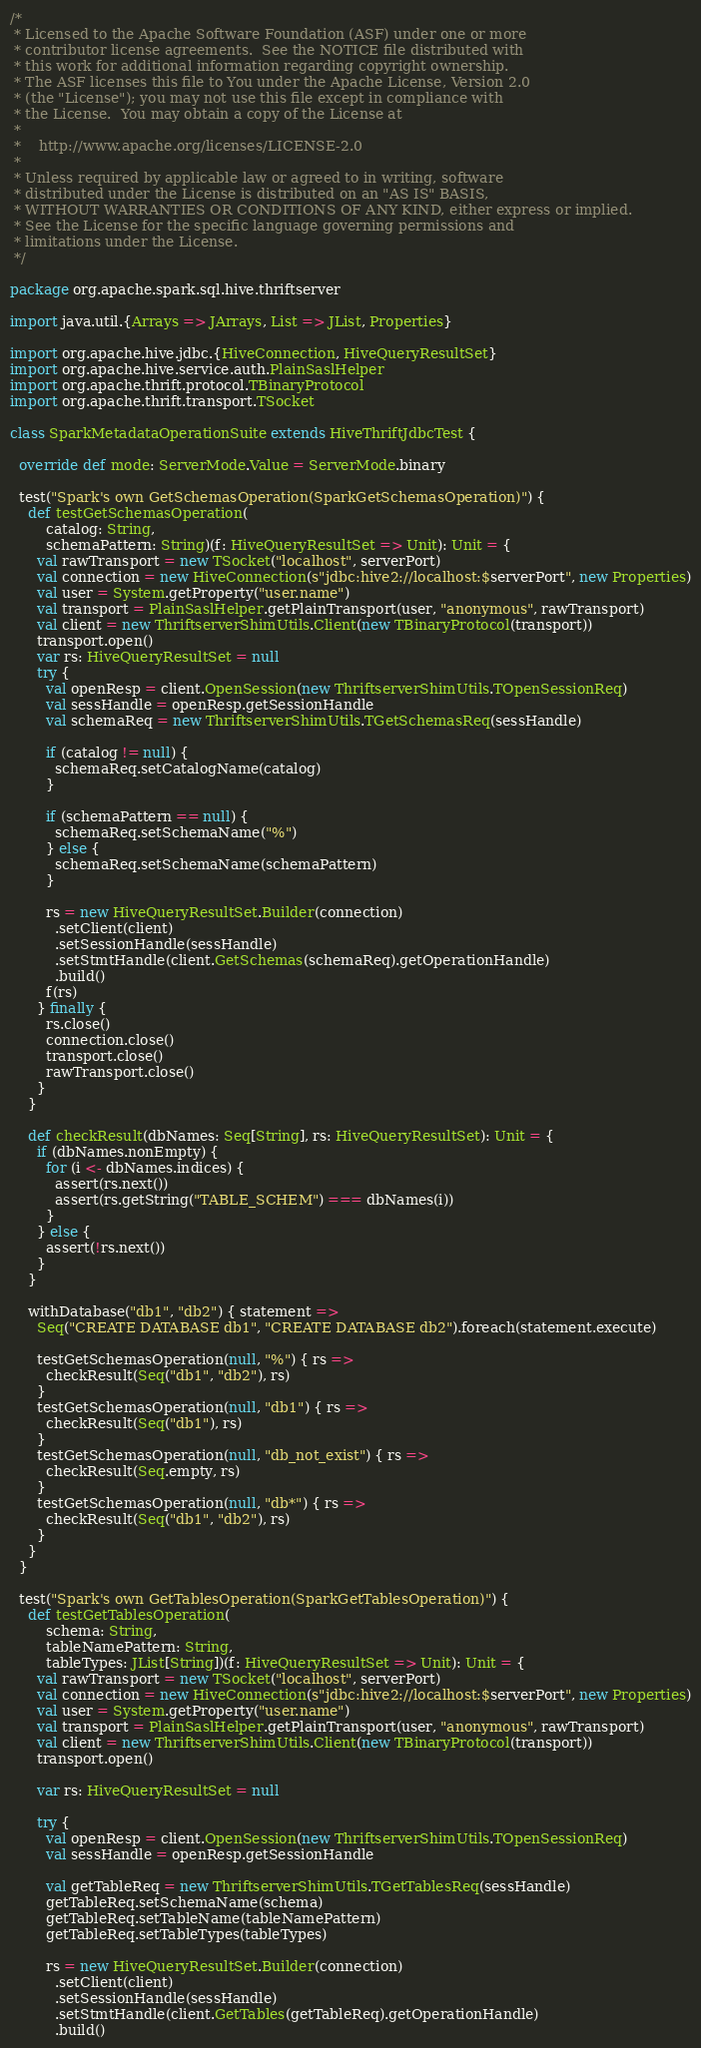<code> <loc_0><loc_0><loc_500><loc_500><_Scala_>/*
 * Licensed to the Apache Software Foundation (ASF) under one or more
 * contributor license agreements.  See the NOTICE file distributed with
 * this work for additional information regarding copyright ownership.
 * The ASF licenses this file to You under the Apache License, Version 2.0
 * (the "License"); you may not use this file except in compliance with
 * the License.  You may obtain a copy of the License at
 *
 *    http://www.apache.org/licenses/LICENSE-2.0
 *
 * Unless required by applicable law or agreed to in writing, software
 * distributed under the License is distributed on an "AS IS" BASIS,
 * WITHOUT WARRANTIES OR CONDITIONS OF ANY KIND, either express or implied.
 * See the License for the specific language governing permissions and
 * limitations under the License.
 */

package org.apache.spark.sql.hive.thriftserver

import java.util.{Arrays => JArrays, List => JList, Properties}

import org.apache.hive.jdbc.{HiveConnection, HiveQueryResultSet}
import org.apache.hive.service.auth.PlainSaslHelper
import org.apache.thrift.protocol.TBinaryProtocol
import org.apache.thrift.transport.TSocket

class SparkMetadataOperationSuite extends HiveThriftJdbcTest {

  override def mode: ServerMode.Value = ServerMode.binary

  test("Spark's own GetSchemasOperation(SparkGetSchemasOperation)") {
    def testGetSchemasOperation(
        catalog: String,
        schemaPattern: String)(f: HiveQueryResultSet => Unit): Unit = {
      val rawTransport = new TSocket("localhost", serverPort)
      val connection = new HiveConnection(s"jdbc:hive2://localhost:$serverPort", new Properties)
      val user = System.getProperty("user.name")
      val transport = PlainSaslHelper.getPlainTransport(user, "anonymous", rawTransport)
      val client = new ThriftserverShimUtils.Client(new TBinaryProtocol(transport))
      transport.open()
      var rs: HiveQueryResultSet = null
      try {
        val openResp = client.OpenSession(new ThriftserverShimUtils.TOpenSessionReq)
        val sessHandle = openResp.getSessionHandle
        val schemaReq = new ThriftserverShimUtils.TGetSchemasReq(sessHandle)

        if (catalog != null) {
          schemaReq.setCatalogName(catalog)
        }

        if (schemaPattern == null) {
          schemaReq.setSchemaName("%")
        } else {
          schemaReq.setSchemaName(schemaPattern)
        }

        rs = new HiveQueryResultSet.Builder(connection)
          .setClient(client)
          .setSessionHandle(sessHandle)
          .setStmtHandle(client.GetSchemas(schemaReq).getOperationHandle)
          .build()
        f(rs)
      } finally {
        rs.close()
        connection.close()
        transport.close()
        rawTransport.close()
      }
    }

    def checkResult(dbNames: Seq[String], rs: HiveQueryResultSet): Unit = {
      if (dbNames.nonEmpty) {
        for (i <- dbNames.indices) {
          assert(rs.next())
          assert(rs.getString("TABLE_SCHEM") === dbNames(i))
        }
      } else {
        assert(!rs.next())
      }
    }

    withDatabase("db1", "db2") { statement =>
      Seq("CREATE DATABASE db1", "CREATE DATABASE db2").foreach(statement.execute)

      testGetSchemasOperation(null, "%") { rs =>
        checkResult(Seq("db1", "db2"), rs)
      }
      testGetSchemasOperation(null, "db1") { rs =>
        checkResult(Seq("db1"), rs)
      }
      testGetSchemasOperation(null, "db_not_exist") { rs =>
        checkResult(Seq.empty, rs)
      }
      testGetSchemasOperation(null, "db*") { rs =>
        checkResult(Seq("db1", "db2"), rs)
      }
    }
  }

  test("Spark's own GetTablesOperation(SparkGetTablesOperation)") {
    def testGetTablesOperation(
        schema: String,
        tableNamePattern: String,
        tableTypes: JList[String])(f: HiveQueryResultSet => Unit): Unit = {
      val rawTransport = new TSocket("localhost", serverPort)
      val connection = new HiveConnection(s"jdbc:hive2://localhost:$serverPort", new Properties)
      val user = System.getProperty("user.name")
      val transport = PlainSaslHelper.getPlainTransport(user, "anonymous", rawTransport)
      val client = new ThriftserverShimUtils.Client(new TBinaryProtocol(transport))
      transport.open()

      var rs: HiveQueryResultSet = null

      try {
        val openResp = client.OpenSession(new ThriftserverShimUtils.TOpenSessionReq)
        val sessHandle = openResp.getSessionHandle

        val getTableReq = new ThriftserverShimUtils.TGetTablesReq(sessHandle)
        getTableReq.setSchemaName(schema)
        getTableReq.setTableName(tableNamePattern)
        getTableReq.setTableTypes(tableTypes)

        rs = new HiveQueryResultSet.Builder(connection)
          .setClient(client)
          .setSessionHandle(sessHandle)
          .setStmtHandle(client.GetTables(getTableReq).getOperationHandle)
          .build()
</code> 